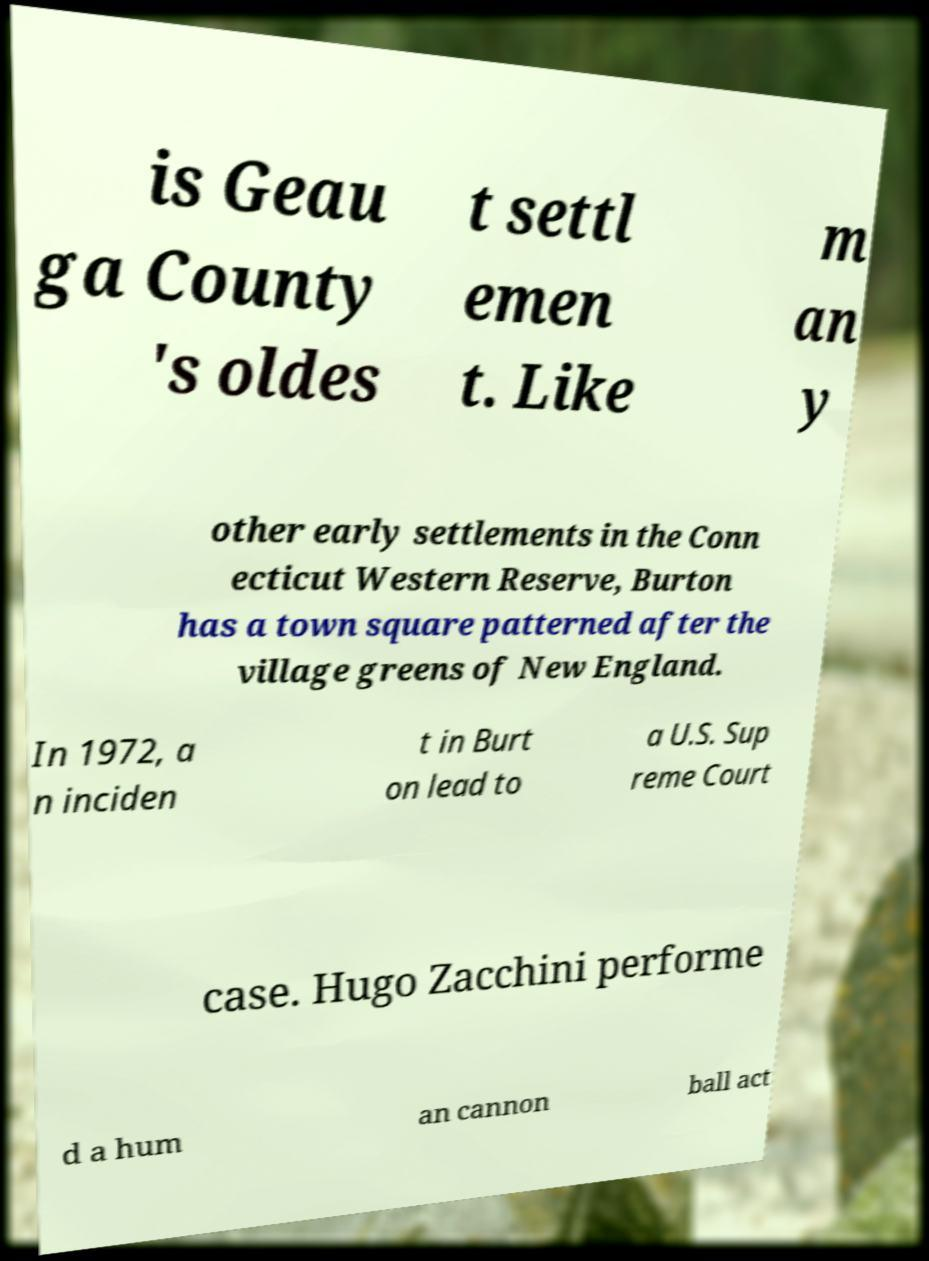There's text embedded in this image that I need extracted. Can you transcribe it verbatim? is Geau ga County 's oldes t settl emen t. Like m an y other early settlements in the Conn ecticut Western Reserve, Burton has a town square patterned after the village greens of New England. In 1972, a n inciden t in Burt on lead to a U.S. Sup reme Court case. Hugo Zacchini performe d a hum an cannon ball act 